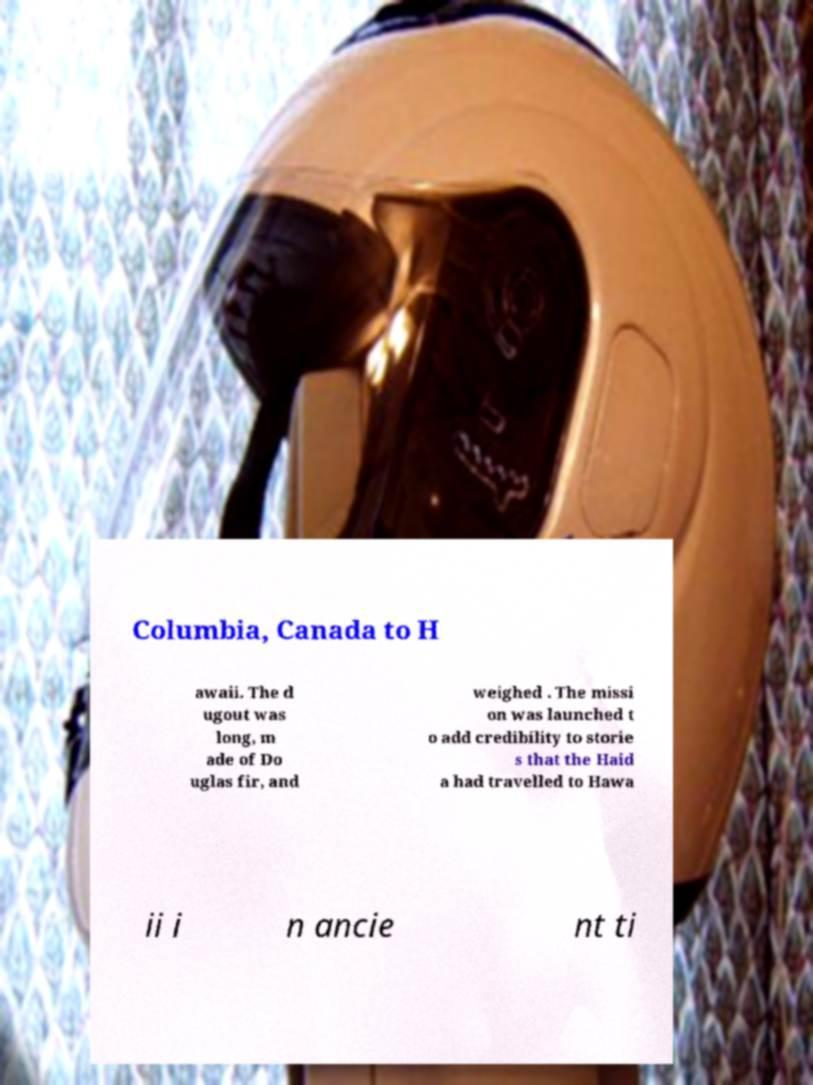Please read and relay the text visible in this image. What does it say? Columbia, Canada to H awaii. The d ugout was long, m ade of Do uglas fir, and weighed . The missi on was launched t o add credibility to storie s that the Haid a had travelled to Hawa ii i n ancie nt ti 